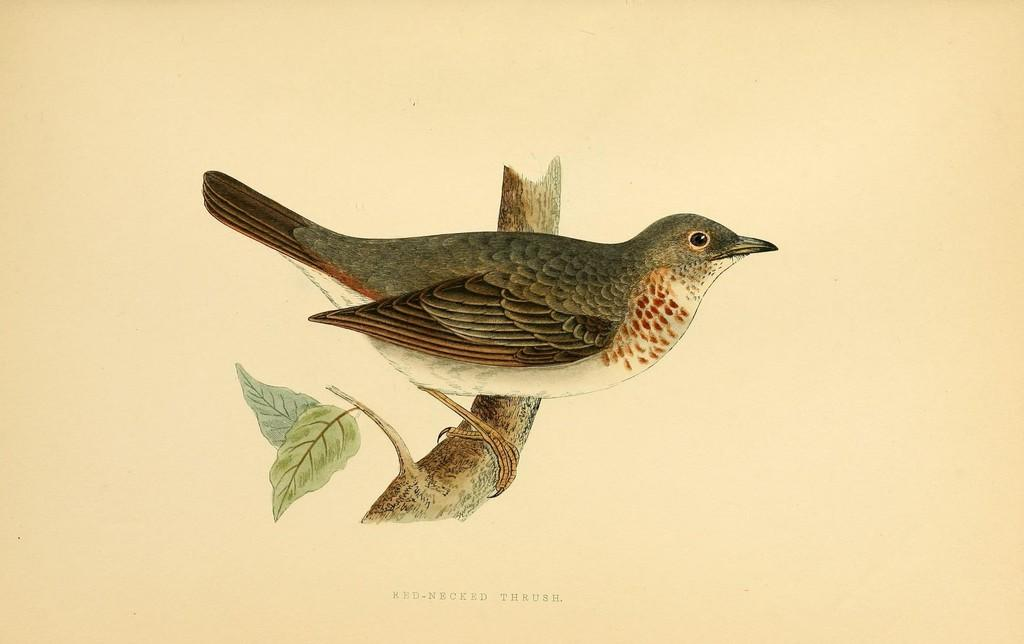What type of visual is depicted in the image? The image is a poster. What is the main subject of the poster? There is a bird in the center of the image. How is the bird positioned in the image? The bird is present on a stem. What other elements can be seen in the image? There are leaves visible in the image. Where is the text located on the poster? Text is present at the bottom of the image. What type of credit card is being advertised at the top of the image? There is no credit card or advertisement present in the image; it features a bird on a stem with leaves and text at the bottom. 